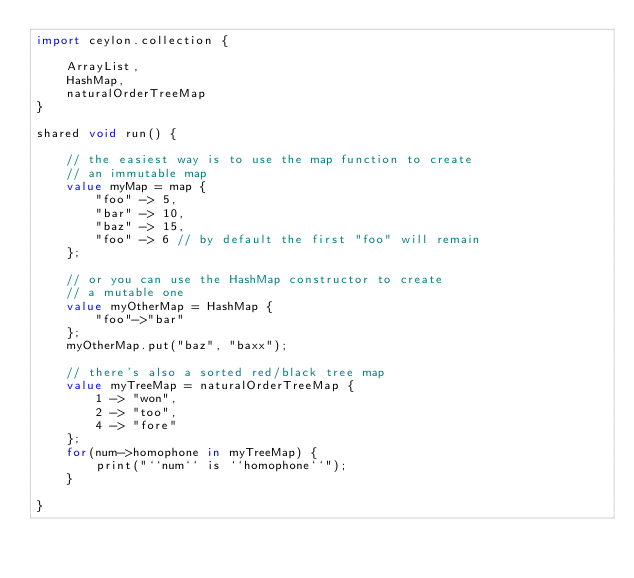<code> <loc_0><loc_0><loc_500><loc_500><_Ceylon_>import ceylon.collection {

	ArrayList,
	HashMap,
	naturalOrderTreeMap
}

shared void run() {
	
	// the easiest way is to use the map function to create
	// an immutable map
	value myMap = map {
		"foo" -> 5,
		"bar" -> 10,
		"baz" -> 15,
		"foo" -> 6 // by default the first "foo" will remain
	};
	
	// or you can use the HashMap constructor to create
	// a mutable one
	value myOtherMap = HashMap {
		"foo"->"bar"
	};
	myOtherMap.put("baz", "baxx");
	
	// there's also a sorted red/black tree map
	value myTreeMap = naturalOrderTreeMap {
		1 -> "won",
		2 -> "too",
		4 -> "fore"
	};
	for(num->homophone in myTreeMap) {
		print("``num`` is ``homophone``");
	}
	
}
</code> 